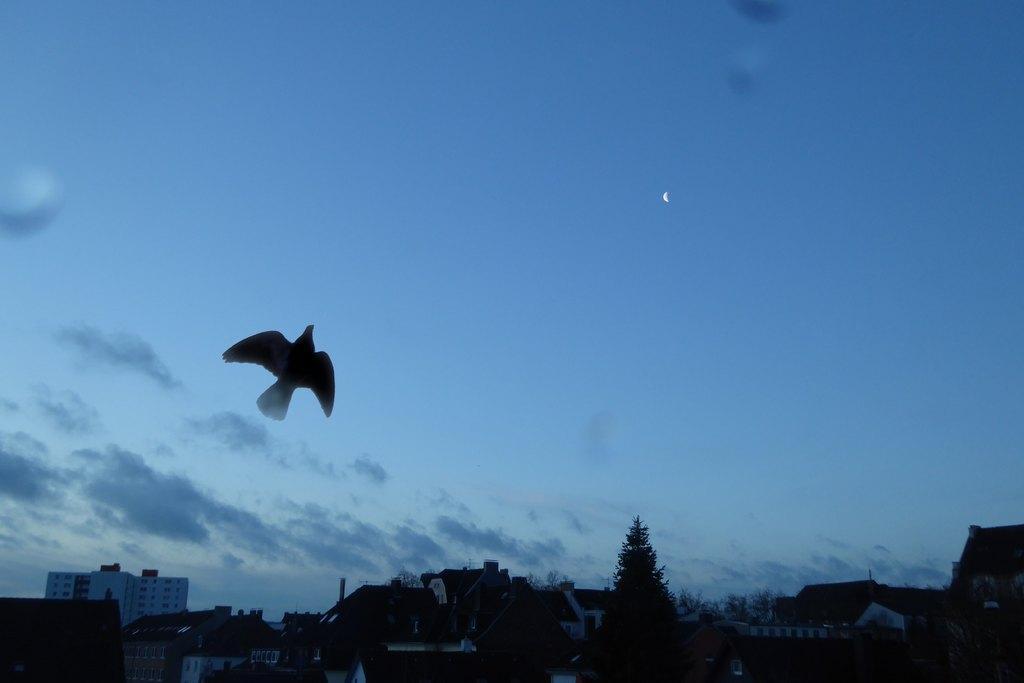Please provide a concise description of this image. In this image I can see a bird. I can see trees and houses. In the background, I can see clouds in the sky. 